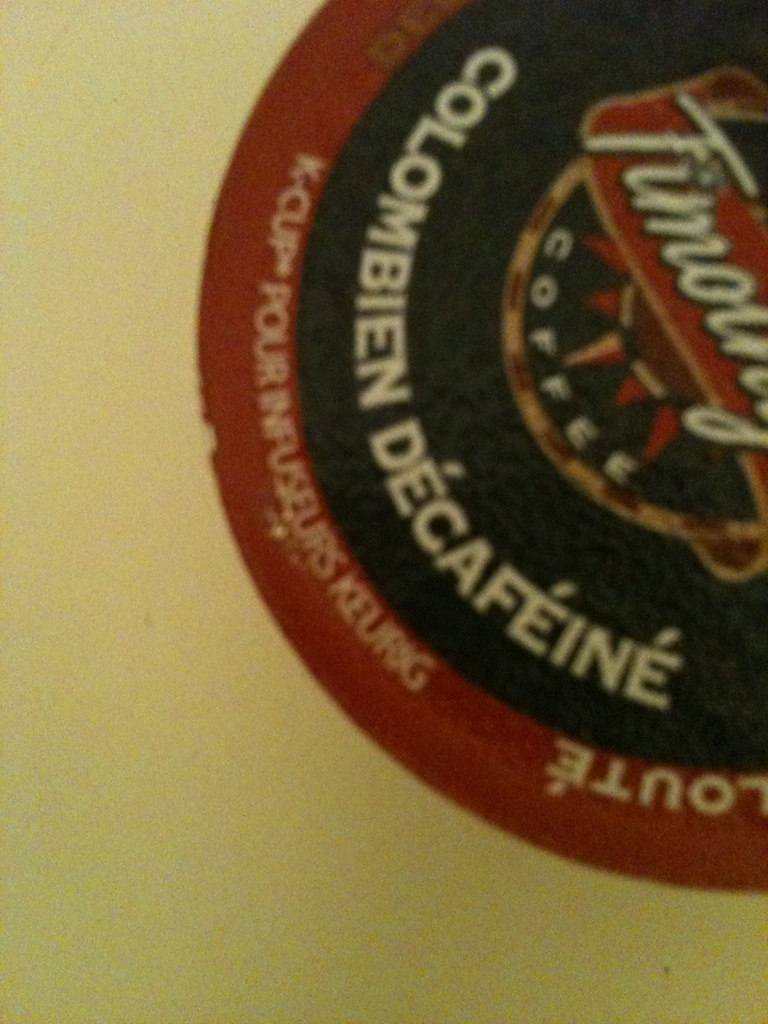Can you tell me more about the origins of Colombian coffee? Colombian coffee is renowned worldwide for its high quality and distinctive taste. The country's unique geography and climate create ideal conditions for coffee cultivation. The mountainous regions provide rich, volcanic soil and varied microclimates, conducive to growing Arabica beans. Farmers often use traditional methods to handpick the cherries, ensuring only the ripest ones are selected. This results in a consistently high-quality product. What makes decaffeinated coffee different from regular coffee? Decaffeinated coffee undergoes a process to remove most of the caffeine content from the coffee beans. This process can be done through various methods such as using water, organic solvents, or carbon dioxide. The goal is to maintain the flavor of the coffee while significantly reducing the caffeine content, making it a popular choice for those who are sensitive to caffeine or who want to avoid it for health reasons. Is there a unique story or legend associated with Colombian coffee? Yes, there's an interesting legend about the discovery of coffee in Colombia. According to folklore, a young goat herder named Kaldi noticed that his goats became exceptionally energetic after eating berries from a certain tree. Curious, Kaldi tried the berries himself and felt a burst of energy. He brought the berries to a local monastery, where the monks made a drink that helped them stay awake during long hours of prayer. This legend, although often associated with the origin of coffee generally rather than specifically Colombian coffee, mirrors the passion and energy that Colombian coffee farmers put into their work to this day. 